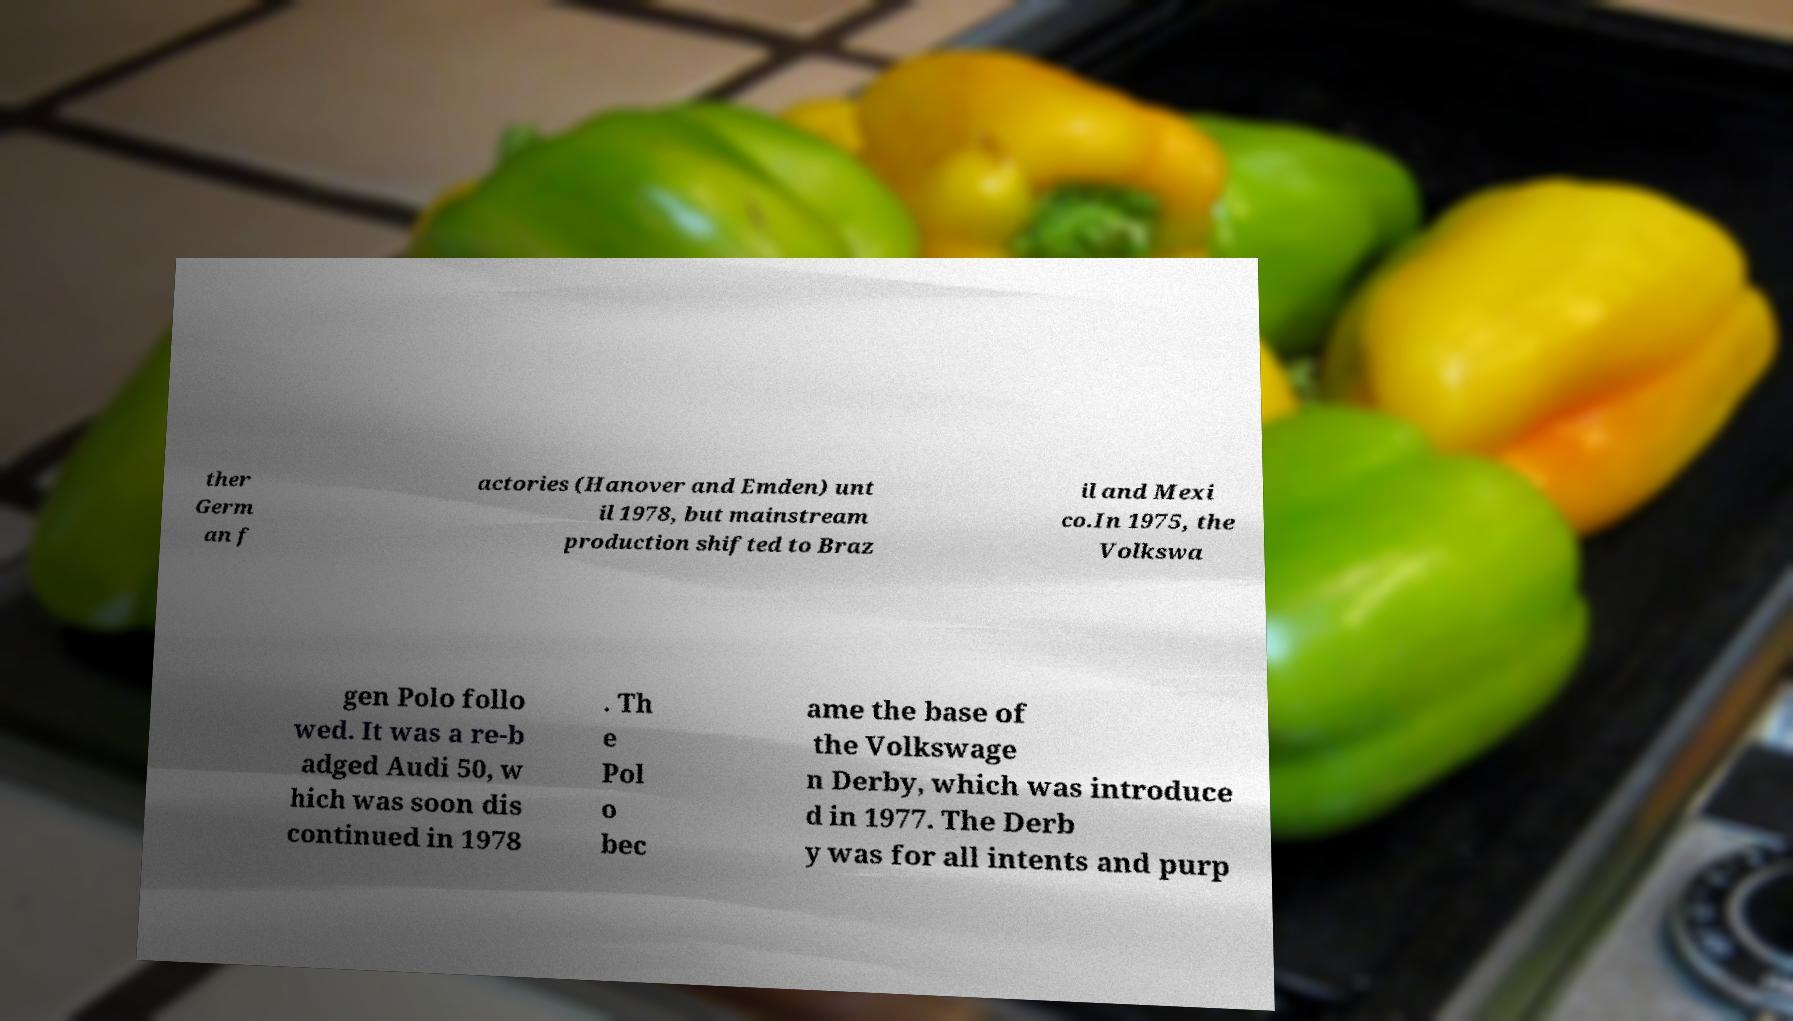Please identify and transcribe the text found in this image. ther Germ an f actories (Hanover and Emden) unt il 1978, but mainstream production shifted to Braz il and Mexi co.In 1975, the Volkswa gen Polo follo wed. It was a re-b adged Audi 50, w hich was soon dis continued in 1978 . Th e Pol o bec ame the base of the Volkswage n Derby, which was introduce d in 1977. The Derb y was for all intents and purp 